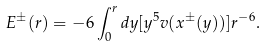<formula> <loc_0><loc_0><loc_500><loc_500>E ^ { \pm } ( r ) = - 6 \int _ { 0 } ^ { r } d y [ y ^ { 5 } v ( x ^ { \pm } ( y ) ) ] r ^ { - 6 } .</formula> 